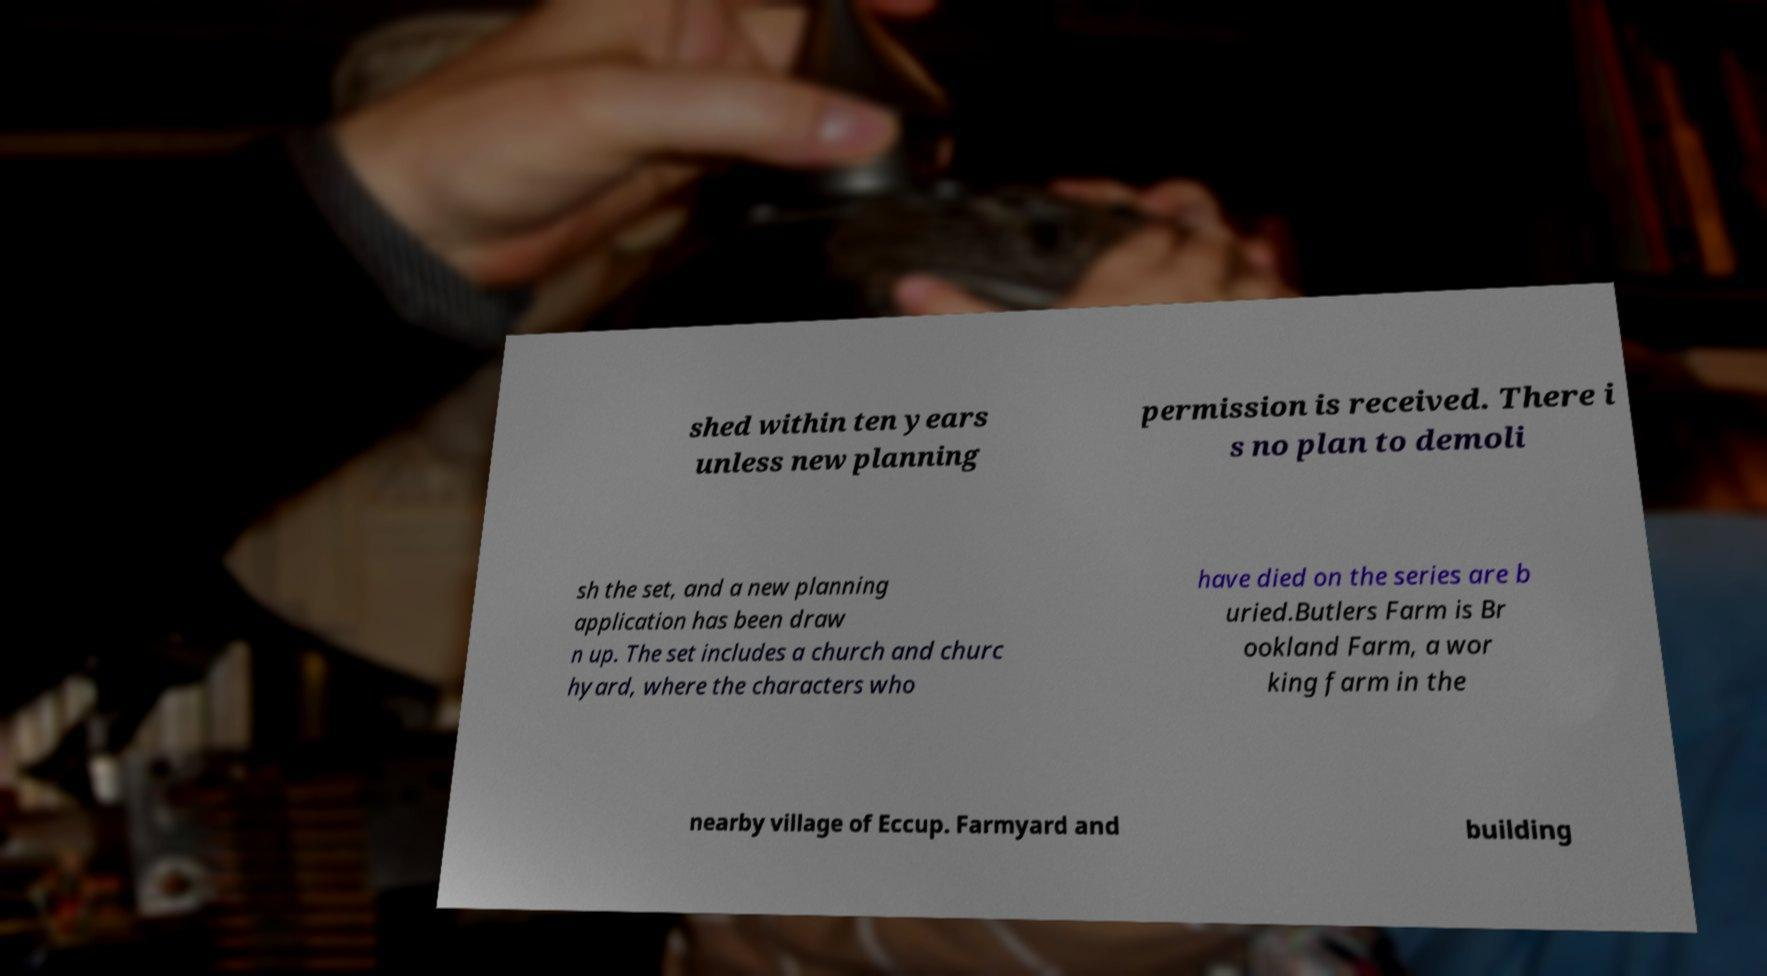There's text embedded in this image that I need extracted. Can you transcribe it verbatim? shed within ten years unless new planning permission is received. There i s no plan to demoli sh the set, and a new planning application has been draw n up. The set includes a church and churc hyard, where the characters who have died on the series are b uried.Butlers Farm is Br ookland Farm, a wor king farm in the nearby village of Eccup. Farmyard and building 